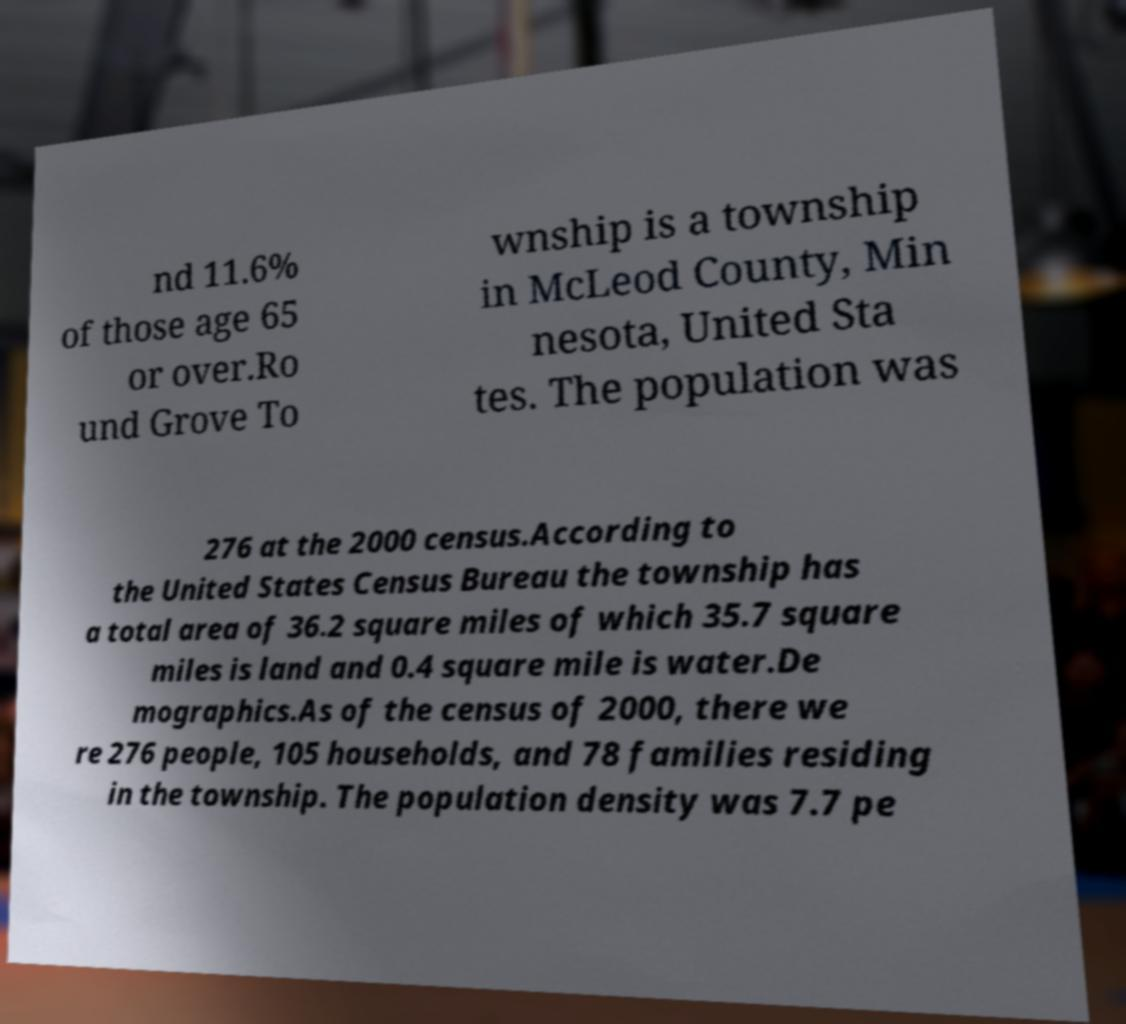What messages or text are displayed in this image? I need them in a readable, typed format. nd 11.6% of those age 65 or over.Ro und Grove To wnship is a township in McLeod County, Min nesota, United Sta tes. The population was 276 at the 2000 census.According to the United States Census Bureau the township has a total area of 36.2 square miles of which 35.7 square miles is land and 0.4 square mile is water.De mographics.As of the census of 2000, there we re 276 people, 105 households, and 78 families residing in the township. The population density was 7.7 pe 